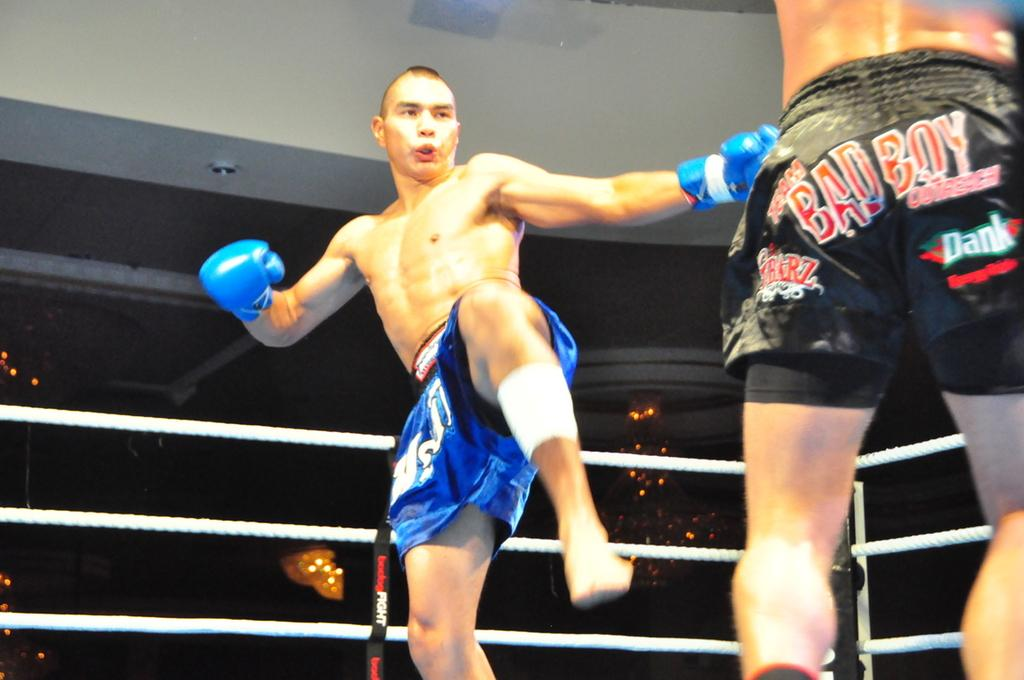<image>
Describe the image concisely. A kick boxer in blue shorts is about to kick at an opponent wearing black bad boy shorts. 